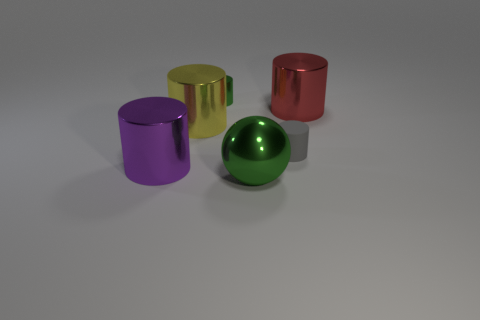Is the color of the shiny sphere the same as the small shiny cylinder?
Offer a terse response. Yes. Are there any other things that are the same shape as the big green metallic object?
Your answer should be very brief. No. What shape is the large metal object that is on the left side of the matte object and to the right of the large yellow metallic cylinder?
Ensure brevity in your answer.  Sphere. What number of green objects are cylinders or large metallic things?
Your answer should be compact. 2. Is the size of the red object that is right of the yellow object the same as the metal object that is behind the red cylinder?
Offer a very short reply. No. What number of things are tiny green metallic cylinders or large gray rubber spheres?
Your answer should be compact. 1. Is there another small gray rubber object of the same shape as the tiny matte object?
Provide a succinct answer. No. Is the number of metallic spheres less than the number of large cylinders?
Ensure brevity in your answer.  Yes. Does the tiny green thing have the same shape as the big purple metallic object?
Provide a short and direct response. Yes. What number of objects are purple metallic cylinders or metal things that are to the right of the large purple cylinder?
Your response must be concise. 5. 